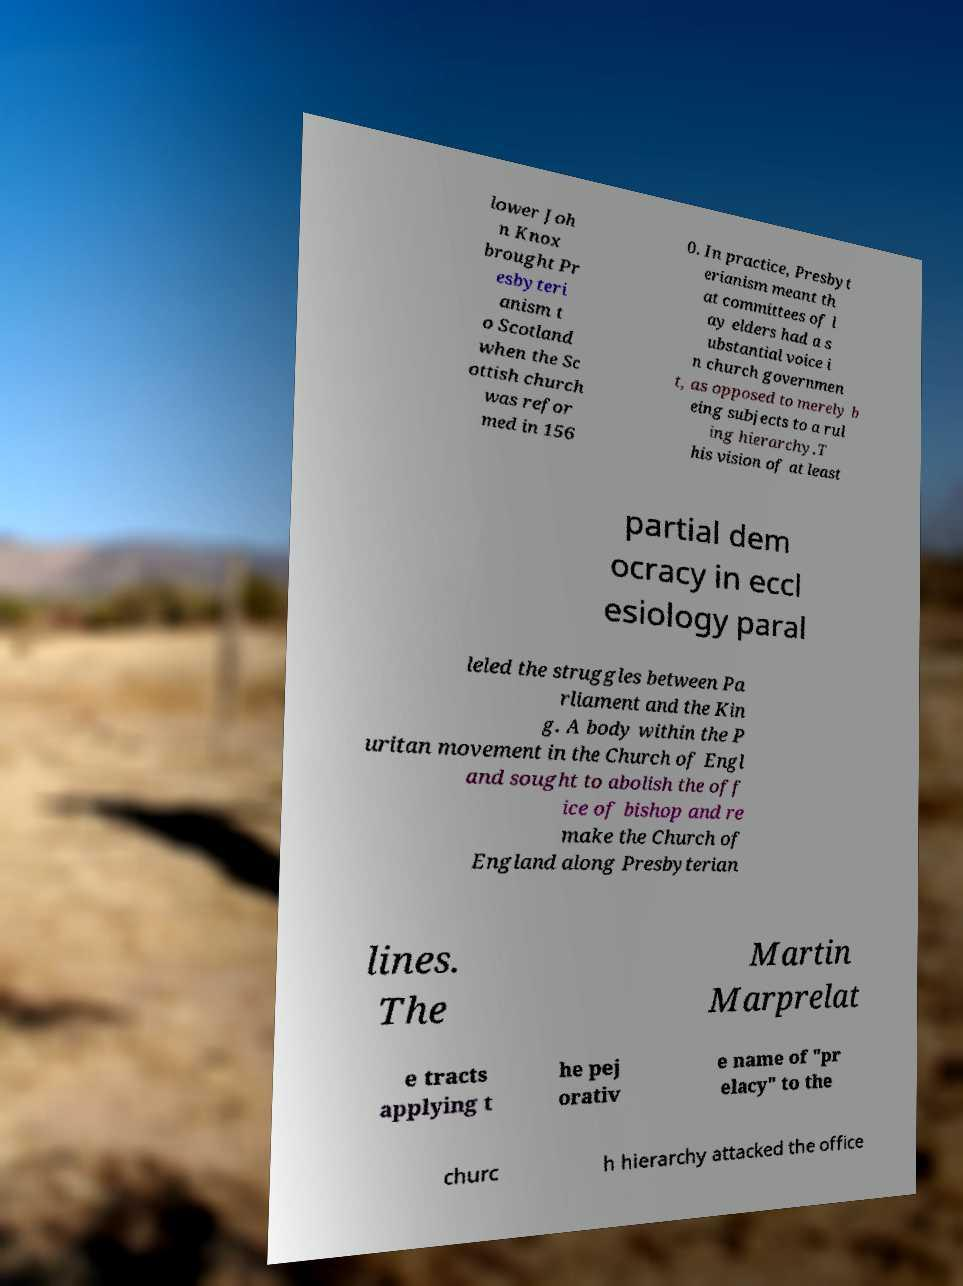Could you assist in decoding the text presented in this image and type it out clearly? lower Joh n Knox brought Pr esbyteri anism t o Scotland when the Sc ottish church was refor med in 156 0. In practice, Presbyt erianism meant th at committees of l ay elders had a s ubstantial voice i n church governmen t, as opposed to merely b eing subjects to a rul ing hierarchy.T his vision of at least partial dem ocracy in eccl esiology paral leled the struggles between Pa rliament and the Kin g. A body within the P uritan movement in the Church of Engl and sought to abolish the off ice of bishop and re make the Church of England along Presbyterian lines. The Martin Marprelat e tracts applying t he pej orativ e name of "pr elacy" to the churc h hierarchy attacked the office 